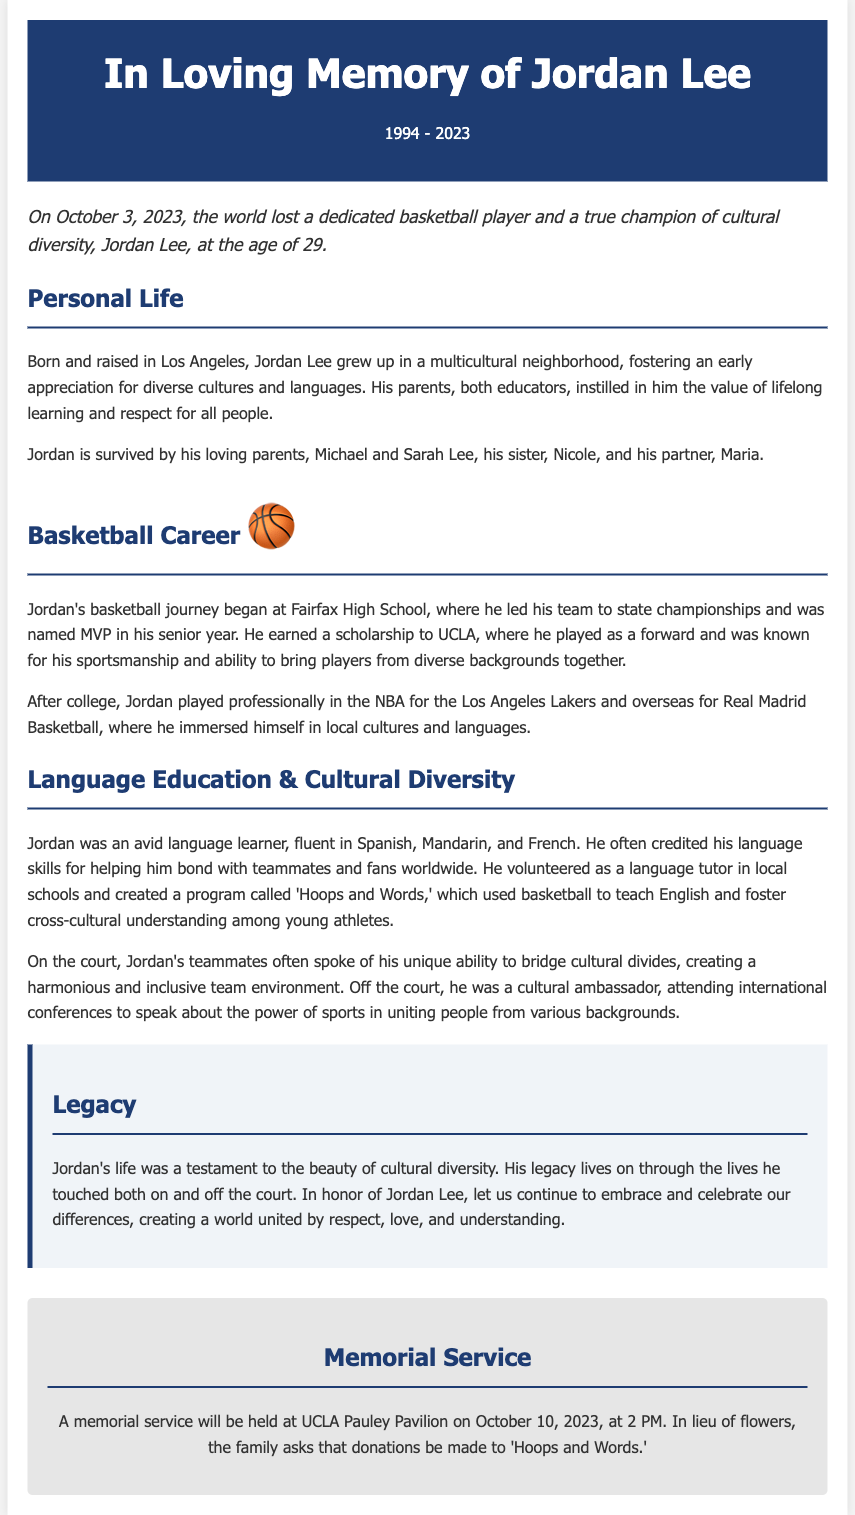What is the name of the person honored in the obituary? The obituary is in memory of Jordan Lee, who is prominently mentioned at the start.
Answer: Jordan Lee What year was Jordan Lee born? The obituary states that Jordan Lee was born in 1994, as indicated in the header.
Answer: 1994 What was Jordan’s role on his college basketball team? The document mentions that he played as a forward at UCLA.
Answer: Forward Which NBA team did Jordan play for? The obituary specifies that he played professionally for the Los Angeles Lakers.
Answer: Los Angeles Lakers What program did Jordan create to teach language? The obituary details a program called 'Hoops and Words', aimed at language education.
Answer: Hoops and Words How many languages was Jordan fluent in? The text lists three languages in which he was fluent, indicating his language skills.
Answer: Three What date was Jordan Lee's memorial service scheduled? The document clearly states that the memorial service will be held on October 10, 2023.
Answer: October 10, 2023 What is the significance of Jordan's legacy according to the obituary? The legacy reflects the importance of embracing cultural diversity, as described in the text.
Answer: Embracing cultural diversity What recognition did Jordan Lee receive in his senior year at high school? The obituary mentions that he was named MVP in his senior year at Fairfax High School.
Answer: MVP 